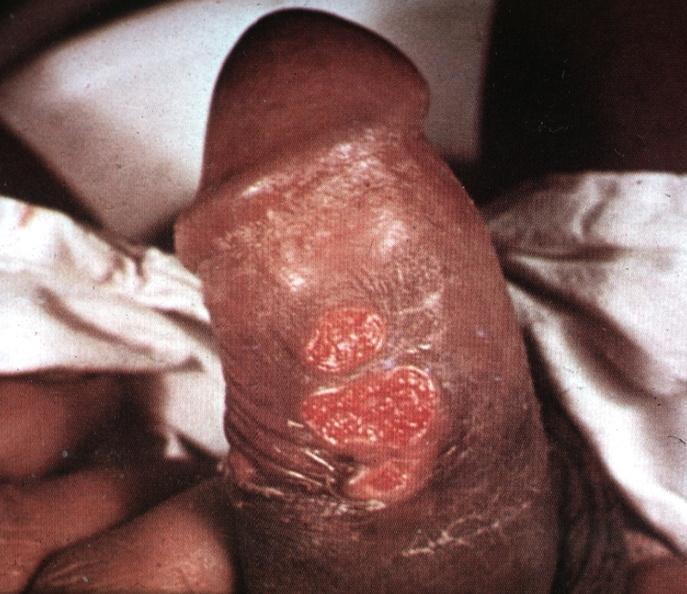does this image show that ulcerative lesions slide is labeled chancroid?
Answer the question using a single word or phrase. Yes 